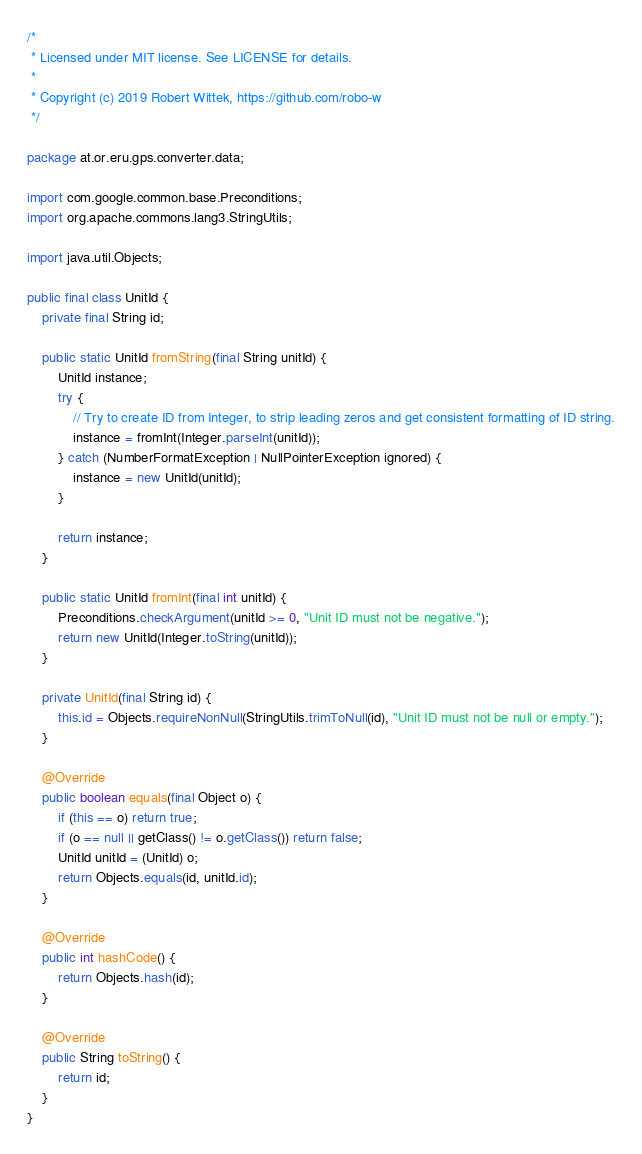<code> <loc_0><loc_0><loc_500><loc_500><_Java_>/*
 * Licensed under MIT license. See LICENSE for details.
 *
 * Copyright (c) 2019 Robert Wittek, https://github.com/robo-w
 */

package at.or.eru.gps.converter.data;

import com.google.common.base.Preconditions;
import org.apache.commons.lang3.StringUtils;

import java.util.Objects;

public final class UnitId {
    private final String id;

    public static UnitId fromString(final String unitId) {
        UnitId instance;
        try {
            // Try to create ID from Integer, to strip leading zeros and get consistent formatting of ID string.
            instance = fromInt(Integer.parseInt(unitId));
        } catch (NumberFormatException | NullPointerException ignored) {
            instance = new UnitId(unitId);
        }

        return instance;
    }

    public static UnitId fromInt(final int unitId) {
        Preconditions.checkArgument(unitId >= 0, "Unit ID must not be negative.");
        return new UnitId(Integer.toString(unitId));
    }

    private UnitId(final String id) {
        this.id = Objects.requireNonNull(StringUtils.trimToNull(id), "Unit ID must not be null or empty.");
    }

    @Override
    public boolean equals(final Object o) {
        if (this == o) return true;
        if (o == null || getClass() != o.getClass()) return false;
        UnitId unitId = (UnitId) o;
        return Objects.equals(id, unitId.id);
    }

    @Override
    public int hashCode() {
        return Objects.hash(id);
    }

    @Override
    public String toString() {
        return id;
    }
}
</code> 